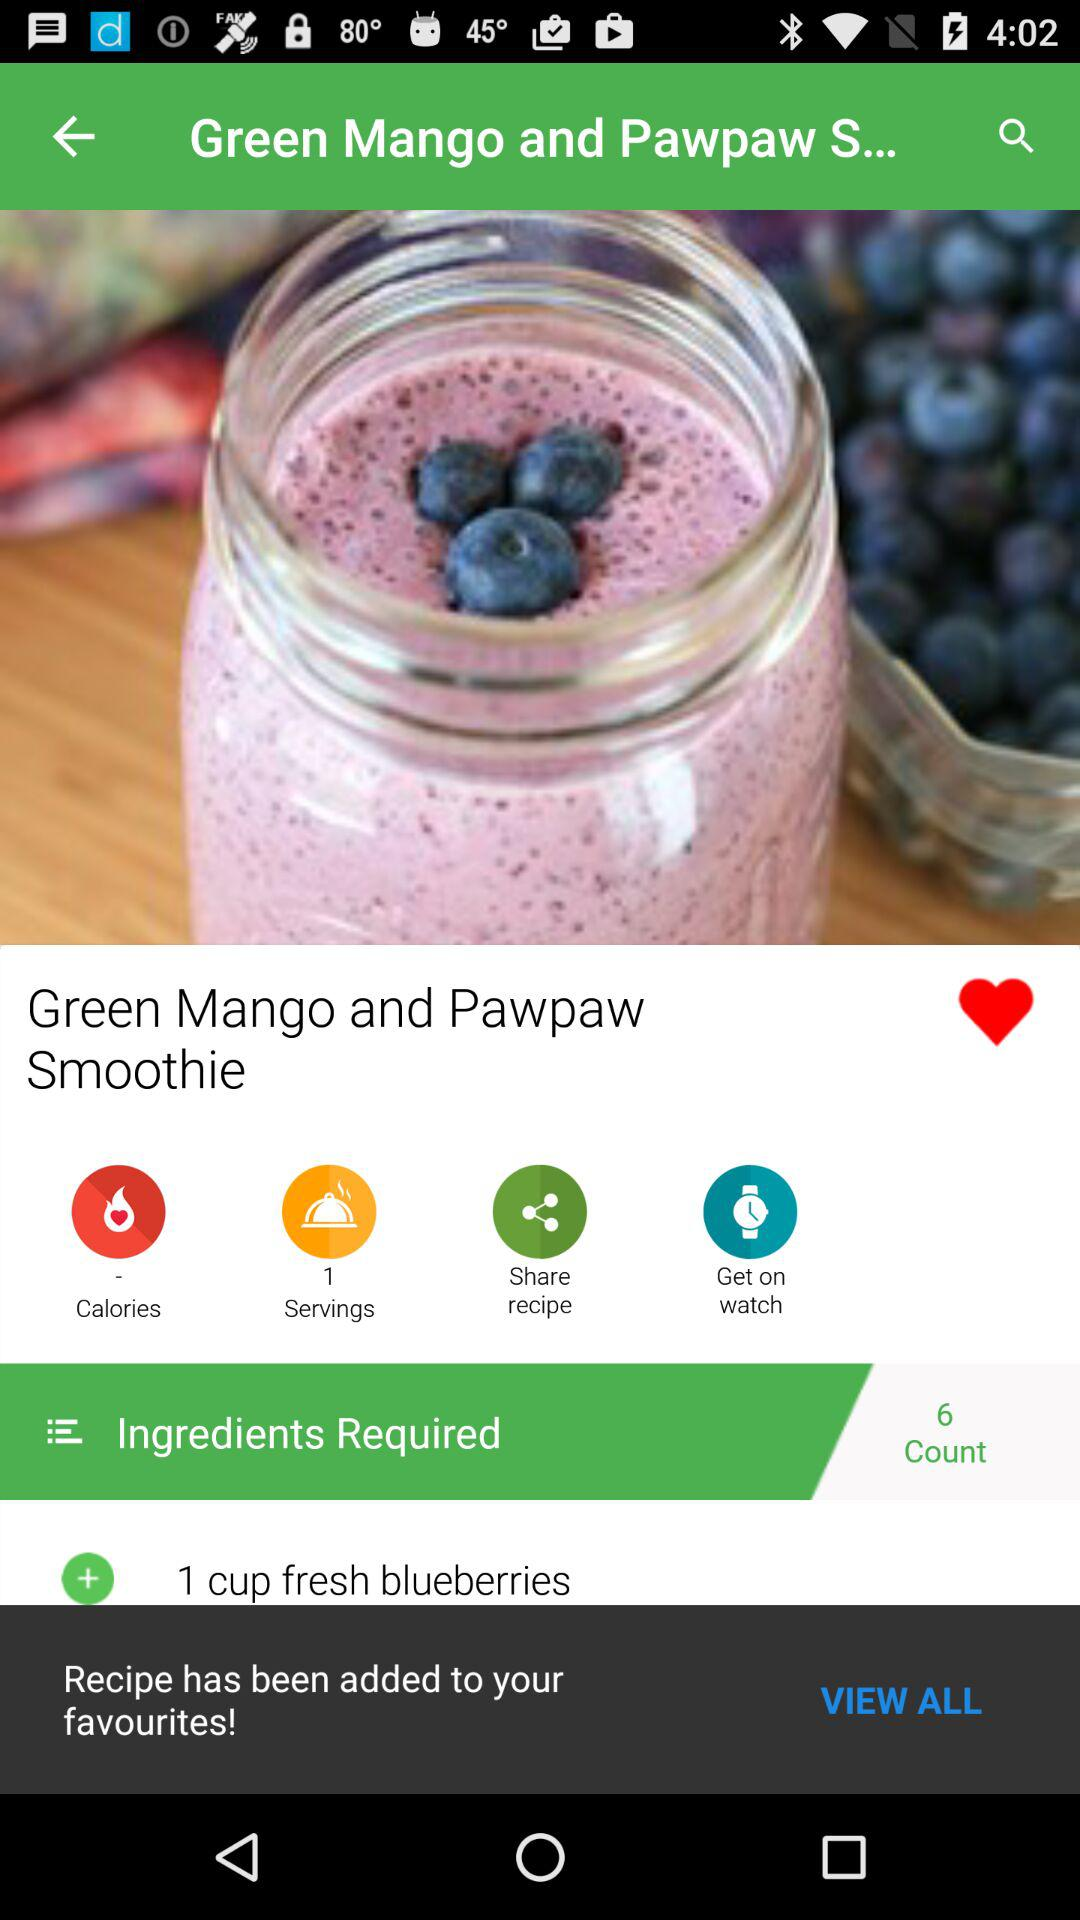How many calories are in this dish?
When the provided information is insufficient, respond with <no answer>. <no answer> 